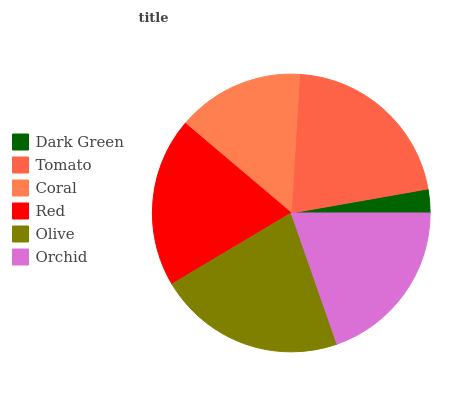Is Dark Green the minimum?
Answer yes or no. Yes. Is Olive the maximum?
Answer yes or no. Yes. Is Tomato the minimum?
Answer yes or no. No. Is Tomato the maximum?
Answer yes or no. No. Is Tomato greater than Dark Green?
Answer yes or no. Yes. Is Dark Green less than Tomato?
Answer yes or no. Yes. Is Dark Green greater than Tomato?
Answer yes or no. No. Is Tomato less than Dark Green?
Answer yes or no. No. Is Red the high median?
Answer yes or no. Yes. Is Orchid the low median?
Answer yes or no. Yes. Is Olive the high median?
Answer yes or no. No. Is Coral the low median?
Answer yes or no. No. 